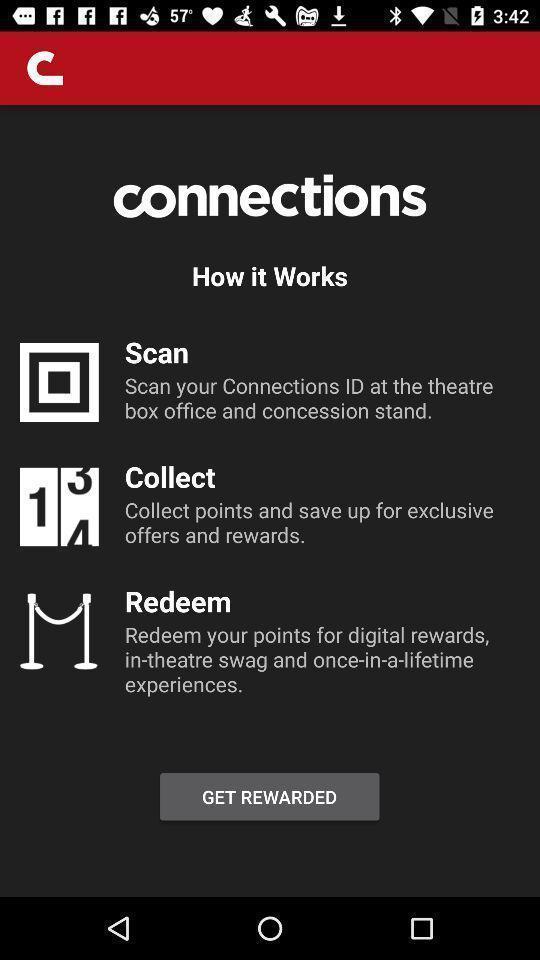Please provide a description for this image. Welcome page of an entertainment app. 